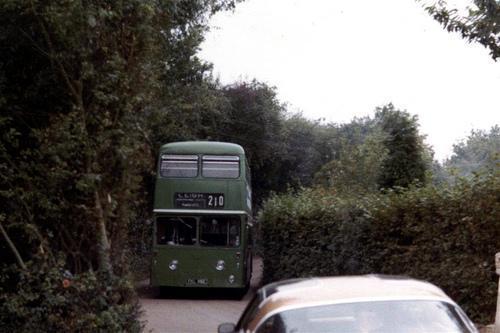How many decks does the bus have?
Give a very brief answer. 2. How many white trucks can you see?
Give a very brief answer. 0. 